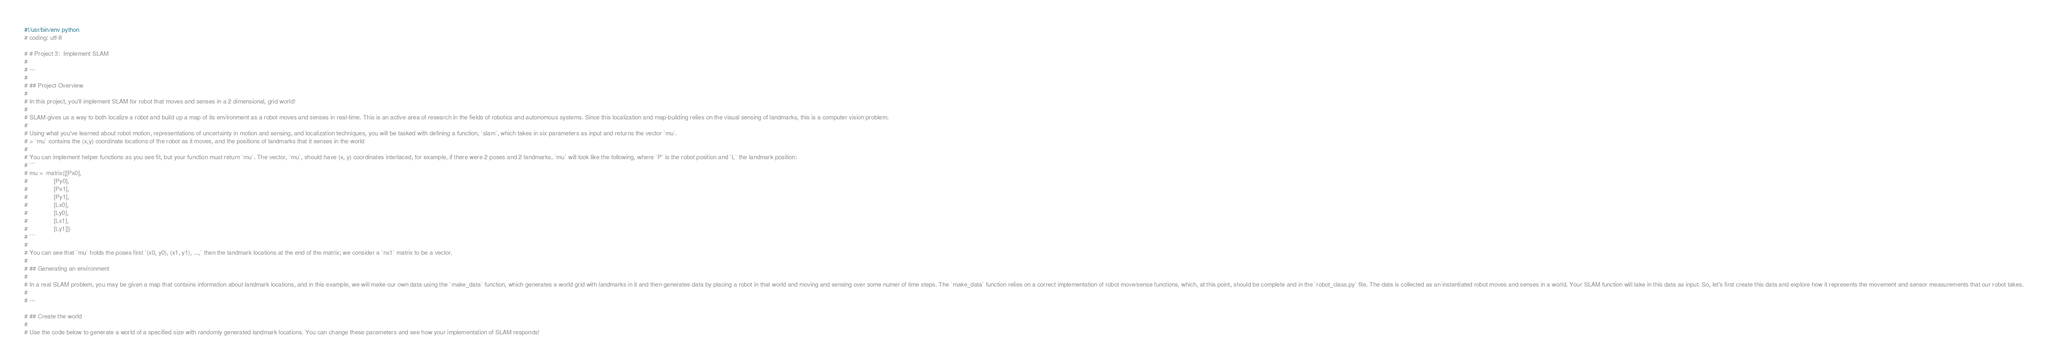<code> <loc_0><loc_0><loc_500><loc_500><_Python_>#!/usr/bin/env python
# coding: utf-8

# # Project 3:  Implement SLAM 
# 
# ---
# 
# ## Project Overview
# 
# In this project, you'll implement SLAM for robot that moves and senses in a 2 dimensional, grid world!
# 
# SLAM gives us a way to both localize a robot and build up a map of its environment as a robot moves and senses in real-time. This is an active area of research in the fields of robotics and autonomous systems. Since this localization and map-building relies on the visual sensing of landmarks, this is a computer vision problem. 
# 
# Using what you've learned about robot motion, representations of uncertainty in motion and sensing, and localization techniques, you will be tasked with defining a function, `slam`, which takes in six parameters as input and returns the vector `mu`. 
# > `mu` contains the (x,y) coordinate locations of the robot as it moves, and the positions of landmarks that it senses in the world
# 
# You can implement helper functions as you see fit, but your function must return `mu`. The vector, `mu`, should have (x, y) coordinates interlaced, for example, if there were 2 poses and 2 landmarks, `mu` will look like the following, where `P` is the robot position and `L` the landmark position:
# ```
# mu =  matrix([[Px0],
#               [Py0],
#               [Px1],
#               [Py1],
#               [Lx0],
#               [Ly0],
#               [Lx1],
#               [Ly1]])
# ```
# 
# You can see that `mu` holds the poses first `(x0, y0), (x1, y1), ...,` then the landmark locations at the end of the matrix; we consider a `nx1` matrix to be a vector.
# 
# ## Generating an environment
# 
# In a real SLAM problem, you may be given a map that contains information about landmark locations, and in this example, we will make our own data using the `make_data` function, which generates a world grid with landmarks in it and then generates data by placing a robot in that world and moving and sensing over some numer of time steps. The `make_data` function relies on a correct implementation of robot move/sense functions, which, at this point, should be complete and in the `robot_class.py` file. The data is collected as an instantiated robot moves and senses in a world. Your SLAM function will take in this data as input. So, let's first create this data and explore how it represents the movement and sensor measurements that our robot takes.
# 
# ---

# ## Create the world
# 
# Use the code below to generate a world of a specified size with randomly generated landmark locations. You can change these parameters and see how your implementation of SLAM responds! </code> 